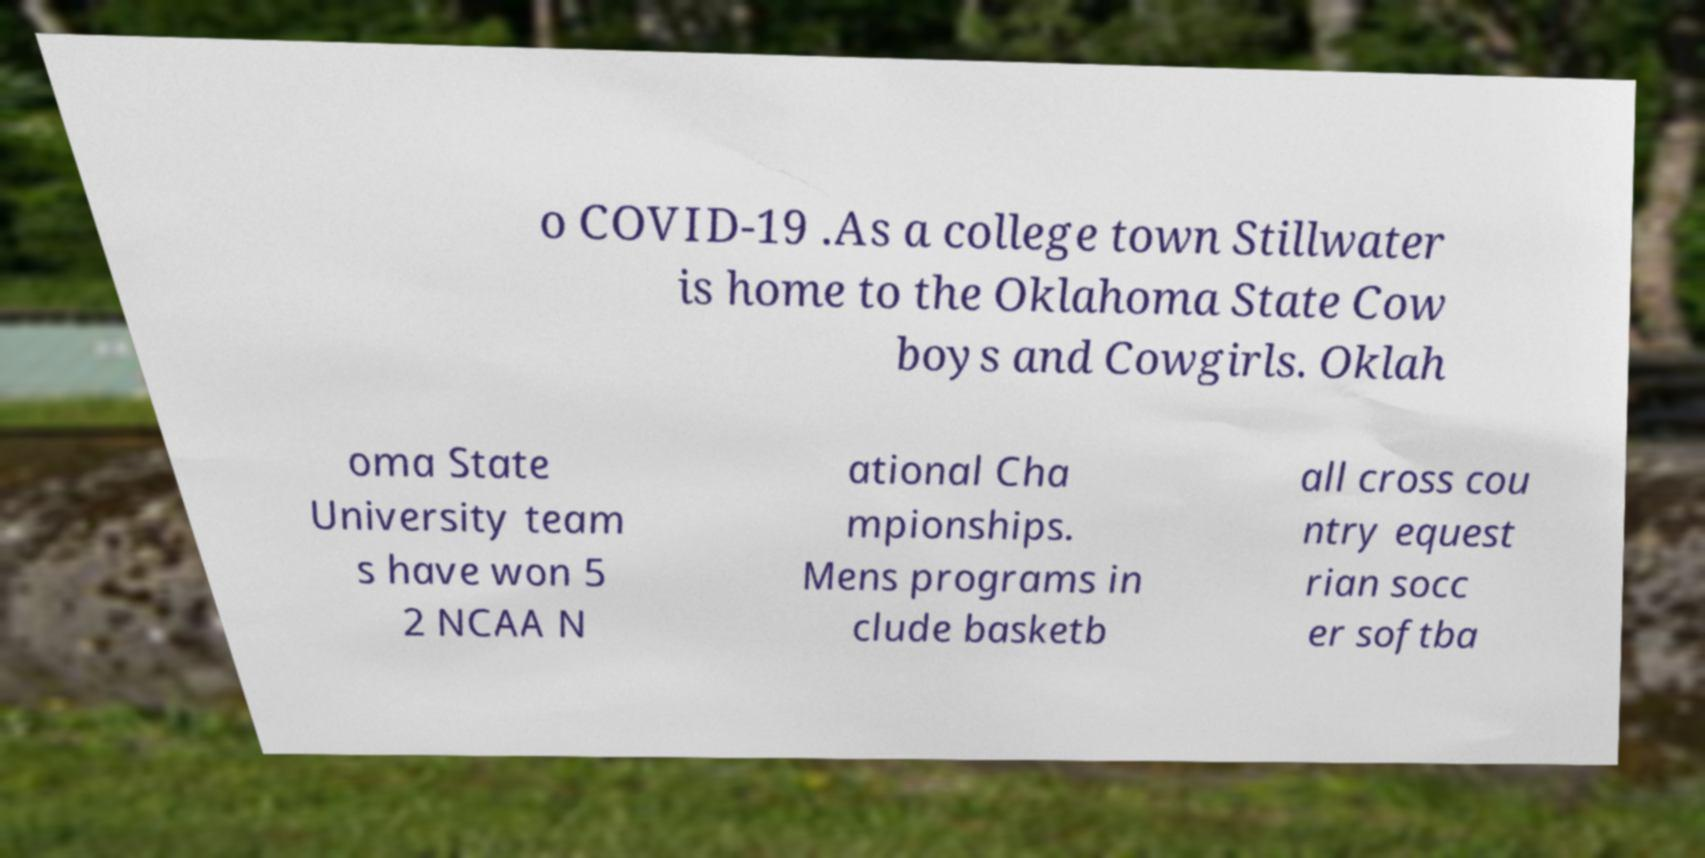What messages or text are displayed in this image? I need them in a readable, typed format. o COVID-19 .As a college town Stillwater is home to the Oklahoma State Cow boys and Cowgirls. Oklah oma State University team s have won 5 2 NCAA N ational Cha mpionships. Mens programs in clude basketb all cross cou ntry equest rian socc er softba 